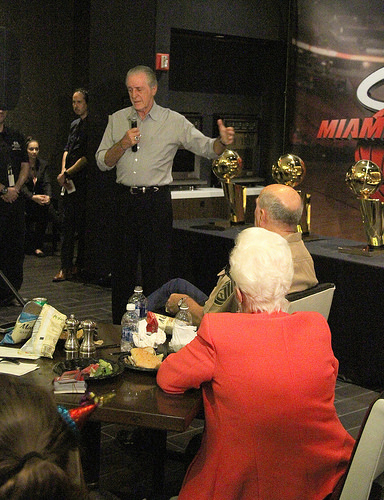<image>
Is there a trophy behind the person? Yes. From this viewpoint, the trophy is positioned behind the person, with the person partially or fully occluding the trophy. Where is the man in relation to the table? Is it behind the table? Yes. From this viewpoint, the man is positioned behind the table, with the table partially or fully occluding the man. 